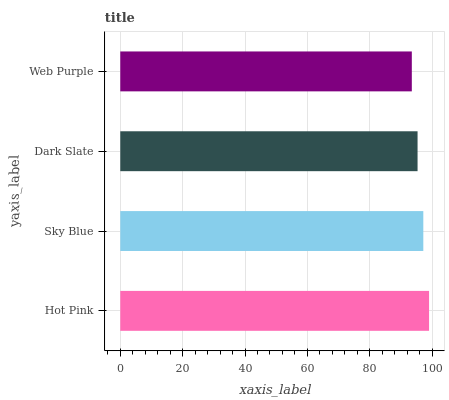Is Web Purple the minimum?
Answer yes or no. Yes. Is Hot Pink the maximum?
Answer yes or no. Yes. Is Sky Blue the minimum?
Answer yes or no. No. Is Sky Blue the maximum?
Answer yes or no. No. Is Hot Pink greater than Sky Blue?
Answer yes or no. Yes. Is Sky Blue less than Hot Pink?
Answer yes or no. Yes. Is Sky Blue greater than Hot Pink?
Answer yes or no. No. Is Hot Pink less than Sky Blue?
Answer yes or no. No. Is Sky Blue the high median?
Answer yes or no. Yes. Is Dark Slate the low median?
Answer yes or no. Yes. Is Hot Pink the high median?
Answer yes or no. No. Is Web Purple the low median?
Answer yes or no. No. 